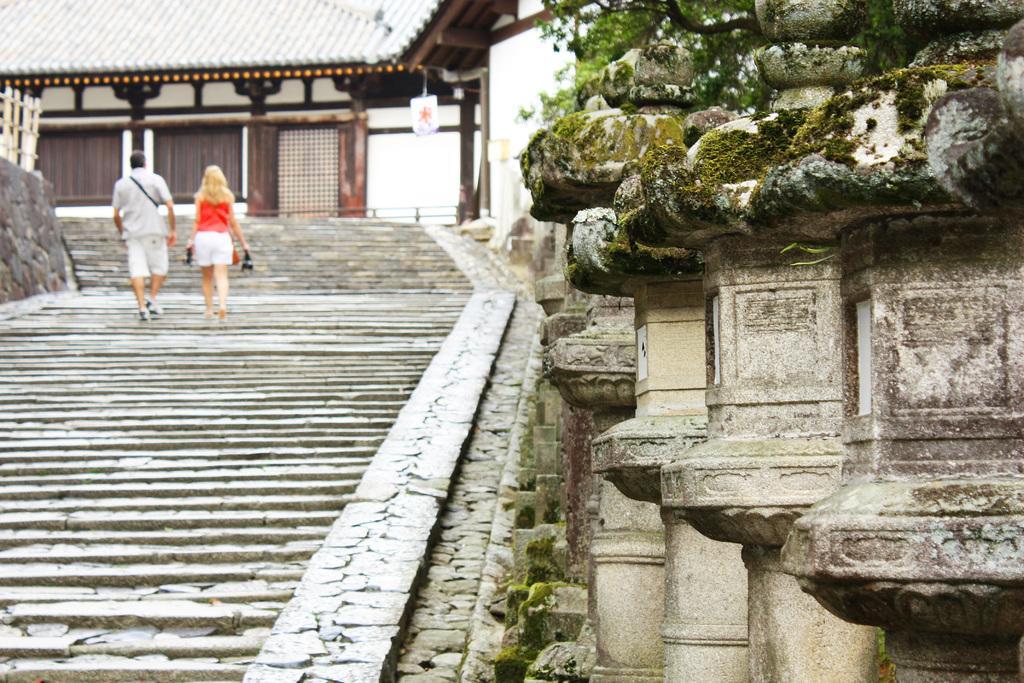How would you summarize this image in a sentence or two? On the left side, there are two persons walking on the steps. On the right side, there are pillars. In the background, there is a building having roof and there is a fencing on the wall. 